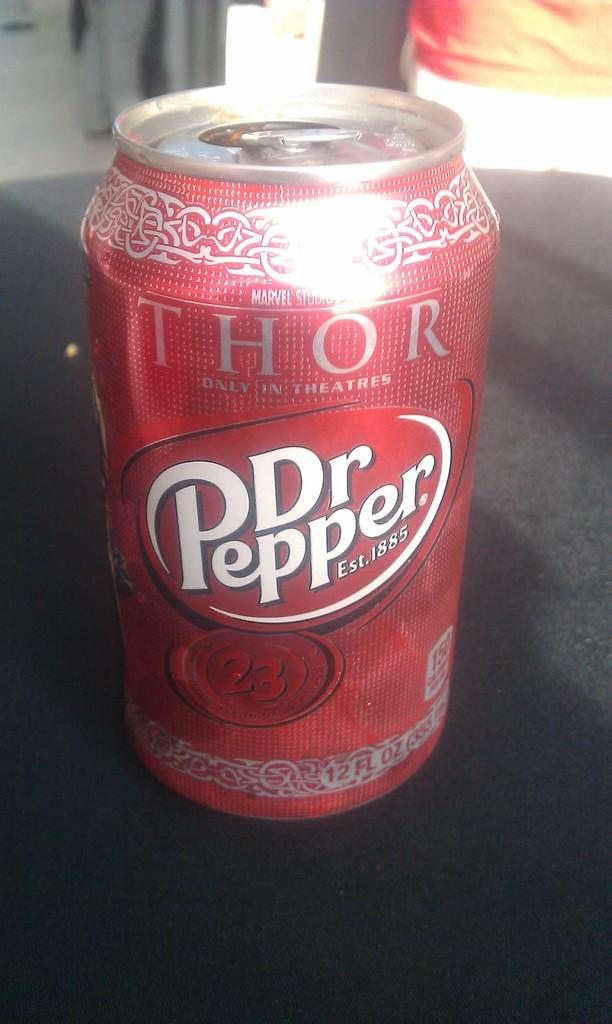What superhero movie is mentioned on the soda can?
Offer a very short reply. Thor. What brand is this soda?
Provide a succinct answer. Dr pepper. 